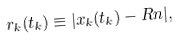<formula> <loc_0><loc_0><loc_500><loc_500>r _ { k } ( t _ { k } ) \equiv | x _ { k } ( t _ { k } ) - R n | ,</formula> 